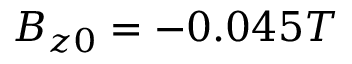<formula> <loc_0><loc_0><loc_500><loc_500>B _ { z 0 } = - 0 . 0 4 5 T</formula> 